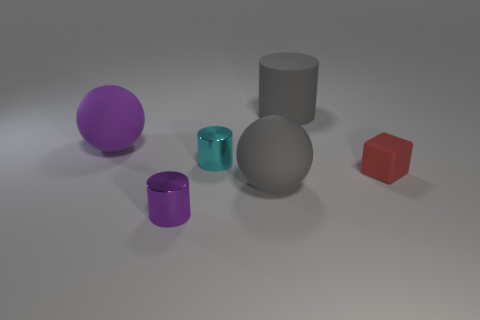Is the number of tiny red matte cubes behind the big gray cylinder less than the number of small red cubes?
Give a very brief answer. Yes. There is a small metal object that is on the right side of the purple cylinder; what is its color?
Make the answer very short. Cyan. There is a large ball that is the same color as the big rubber cylinder; what is it made of?
Keep it short and to the point. Rubber. Is there another tiny purple object that has the same shape as the purple rubber object?
Offer a very short reply. No. How many other objects have the same shape as the cyan shiny thing?
Keep it short and to the point. 2. Do the block and the matte cylinder have the same color?
Offer a terse response. No. Are there fewer shiny things than purple rubber things?
Provide a succinct answer. No. What is the material of the small cylinder to the right of the purple metal object?
Keep it short and to the point. Metal. There is a cyan cylinder that is the same size as the red object; what material is it?
Offer a terse response. Metal. There is a large ball that is behind the ball in front of the small cylinder that is to the right of the purple metallic cylinder; what is its material?
Your answer should be compact. Rubber. 